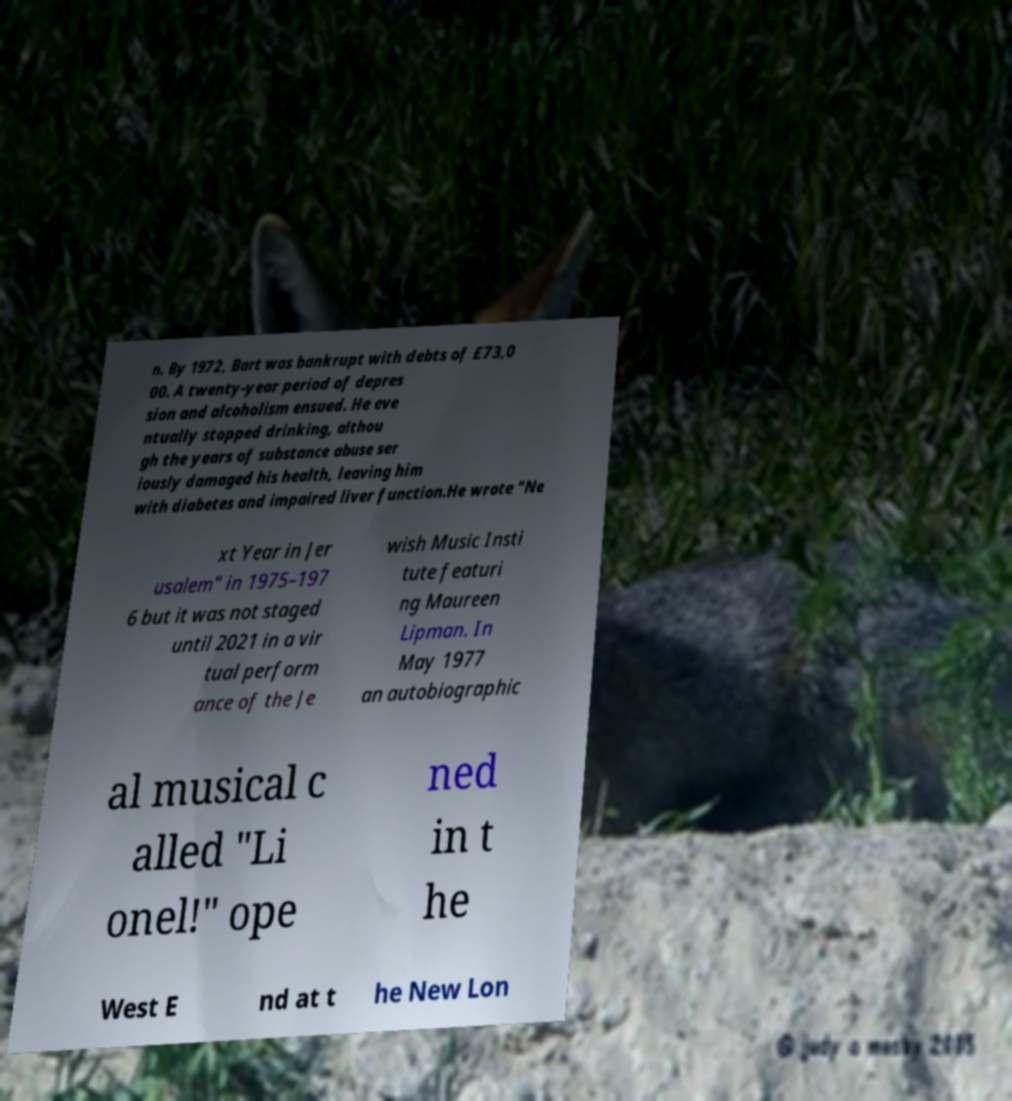I need the written content from this picture converted into text. Can you do that? n. By 1972, Bart was bankrupt with debts of £73,0 00. A twenty-year period of depres sion and alcoholism ensued. He eve ntually stopped drinking, althou gh the years of substance abuse ser iously damaged his health, leaving him with diabetes and impaired liver function.He wrote "Ne xt Year in Jer usalem" in 1975–197 6 but it was not staged until 2021 in a vir tual perform ance of the Je wish Music Insti tute featuri ng Maureen Lipman. In May 1977 an autobiographic al musical c alled "Li onel!" ope ned in t he West E nd at t he New Lon 